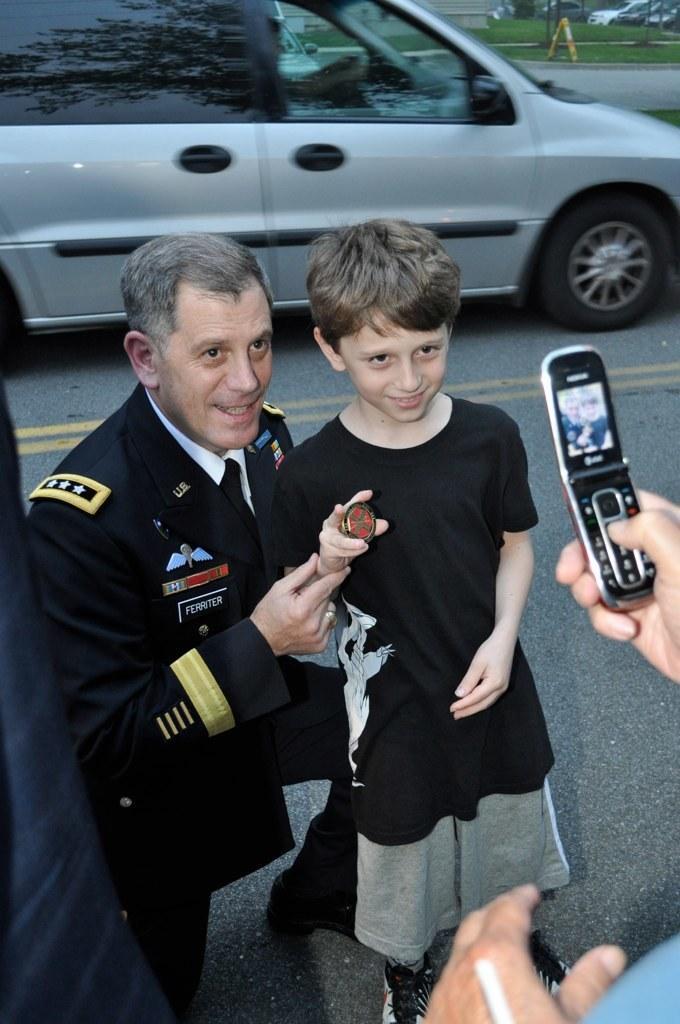How would you summarize this image in a sentence or two? In this image there are two persons, one man and a kid. Both of them are posing to a mobile. In the background there is a car and a grass. 